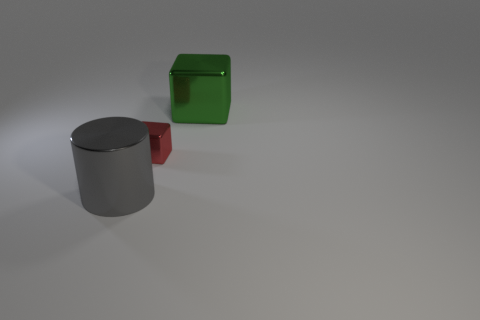Add 1 tiny red metallic blocks. How many objects exist? 4 Subtract all cubes. How many objects are left? 1 Add 3 large purple shiny cylinders. How many large purple shiny cylinders exist? 3 Subtract 0 blue blocks. How many objects are left? 3 Subtract all blocks. Subtract all big purple metal things. How many objects are left? 1 Add 3 small metal things. How many small metal things are left? 4 